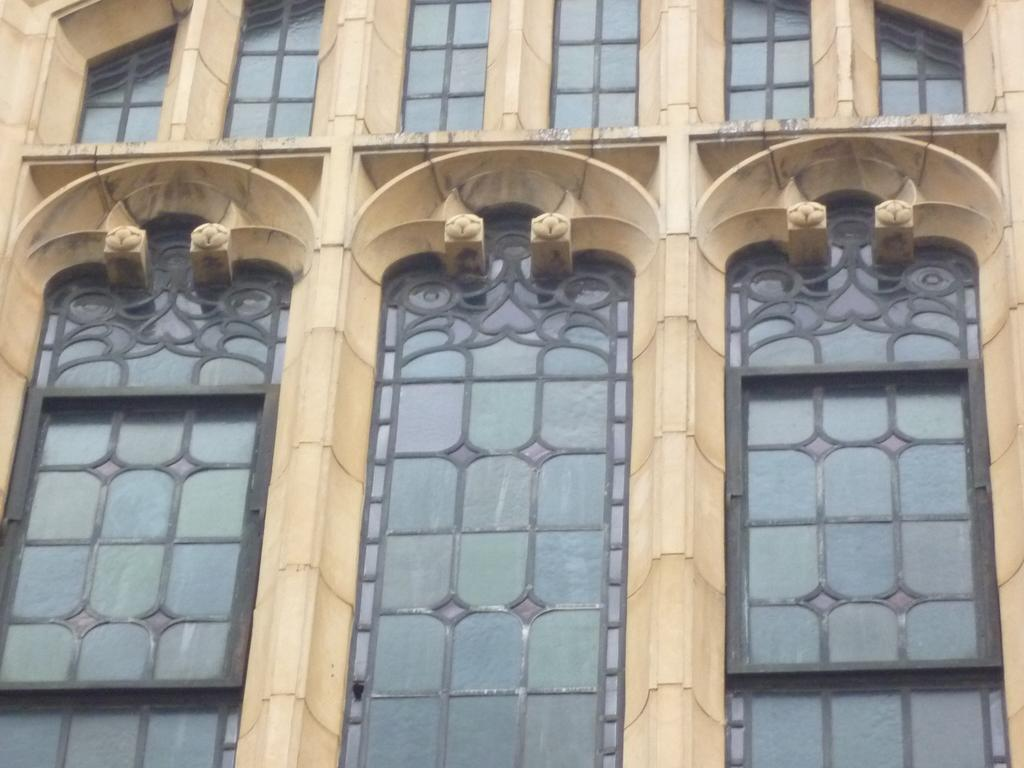What is the main structure visible in the image? There is a building in the image. What feature can be seen on the building? The building has windows. How many fingers can be seen on the building in the image? There are no fingers visible on the building in the image. 